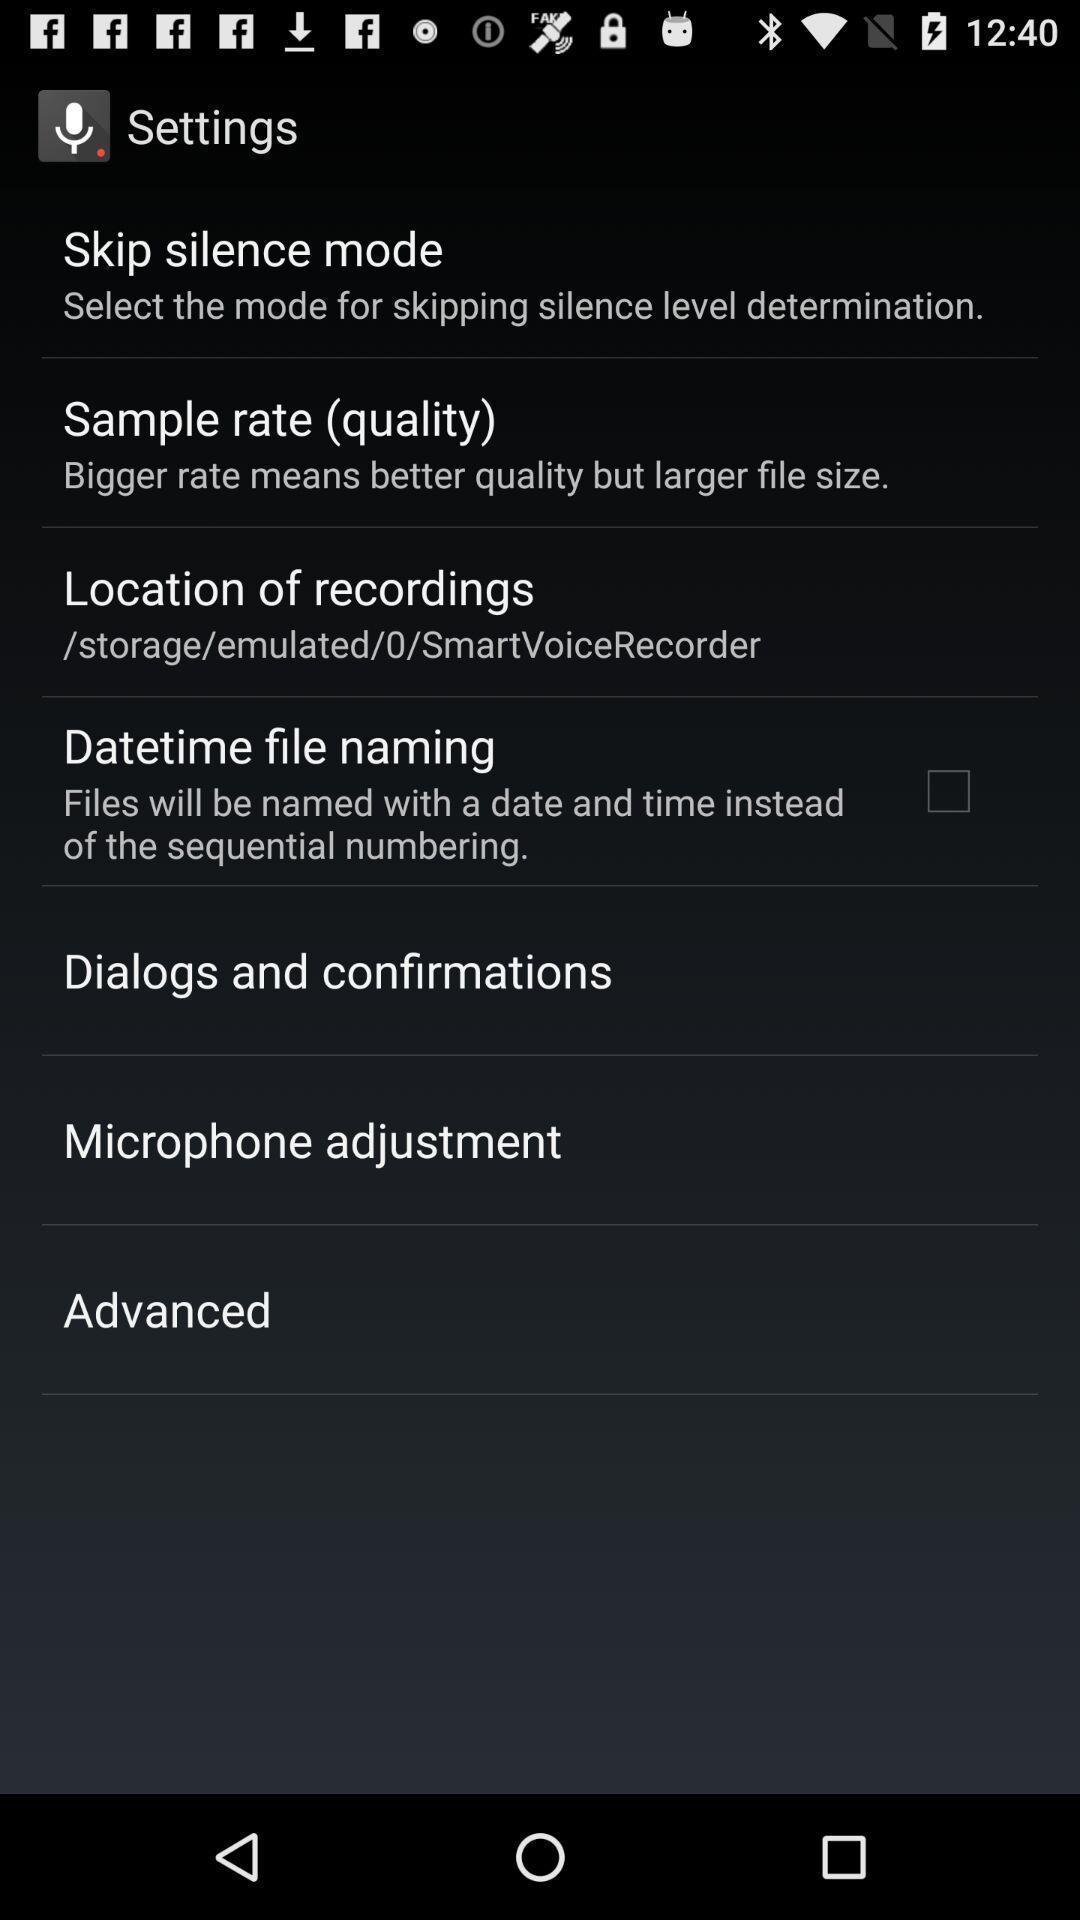Provide a detailed account of this screenshot. Settings page of a recorder app. 